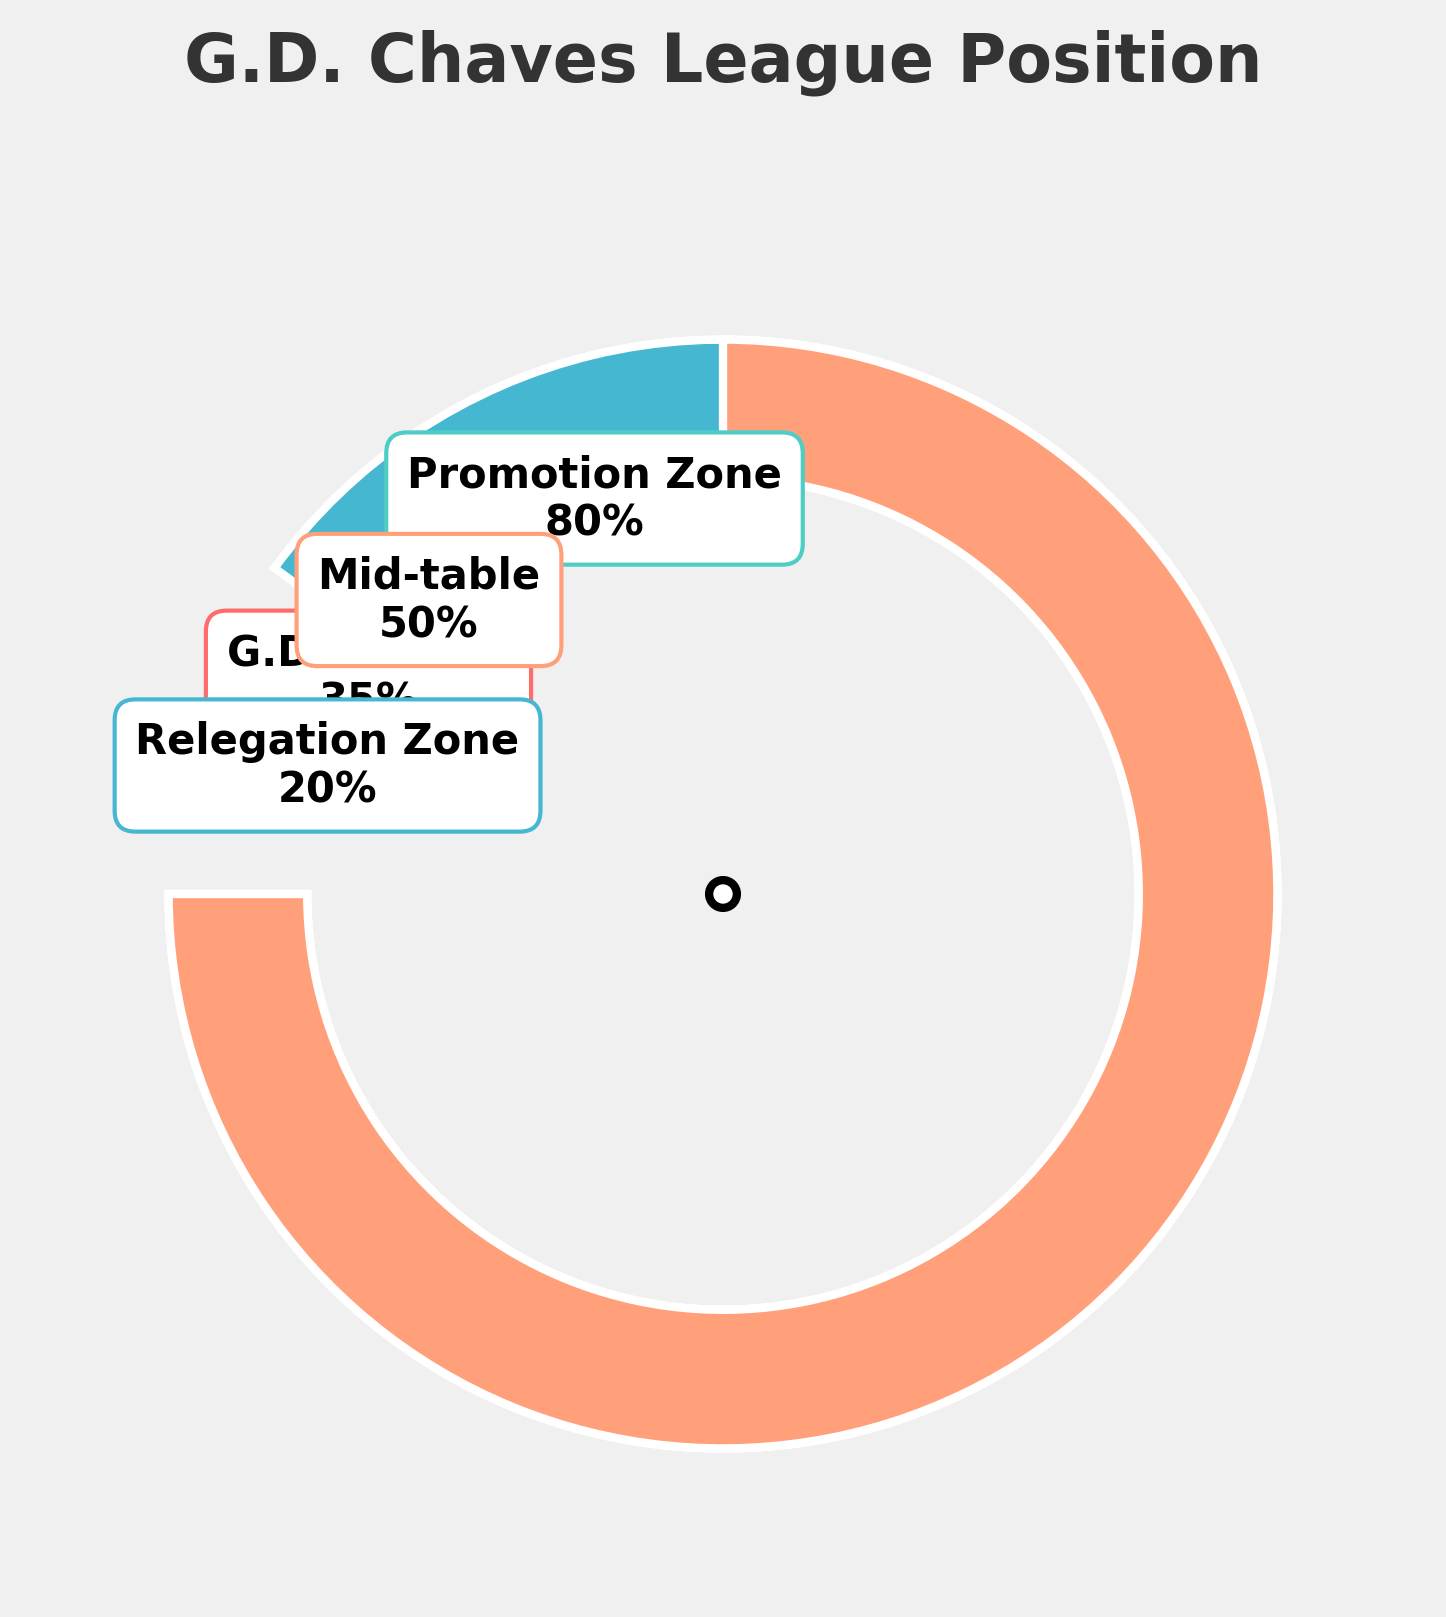what's the title of the figure? The title of the figure can be found at the top and is typically the largest text, centrally aligned.
Answer: "G.D. Chaves League Position" how many regions are represented in the figure? Examining the figure, you can identify the number of labeled segments or regions.
Answer: Four which region has the highest percentage? By comparing the percentages labeled on each segment, you can determine which has the largest value.
Answer: Promotion Zone what percentage is the mid-table region at? Locate the Mid-table segment in the figure and read off the percentage labeled on it.
Answer: 50% how does G.D. Chaves' current percentage compare to the promotion zone percentage? Compare the percentage for G.D. Chaves with the percentage for the Promotion Zone.
Answer: G.D. Chaves' 35% is lower than Promotion Zone's 80% what's the average percentage of all the regions? Sum all the percentages (35 + 80 + 20 + 50) and divide by the number of regions (4). The calculation is (35 + 80 + 20 + 50) / 4 = 185 / 4 = 46.25%.
Answer: 46.25% is G.D. Chaves closer to the mid-table percentage or relegation zone percentage? Calculate the absolute difference between G.D. Chaves' percentage and both the Mid-table (50%) and Relegation Zone (20%) percentages. 50 - 35 = 15 and 35 - 20 = 15. Since both differences are the same, G.D. Chaves is equidistant to both.
Answer: Equidistant what colors represent the regions in the figure? Identify the colors associated with each segment. Note the most distinct and simple description of the colors.
Answer: Red for G.D. Chaves, Teal for Relegation Zone, Blue for Promotion Zone, Orange for Mid-table what's the difference between the Promotion Zone's and Relegation Zone's percentages? Subtract the Relegation Zone percentage (20%) from the Promotion Zone percentage (80%): 80 - 20 = 60
Answer: 60 which region is to the immediate right of G.D. Chaves' gauge? Visual inspection of the segments reveals the orientation of each region. Relegation Zone is immediately to the right of G.D. Chaves.
Answer: Relegation Zone 